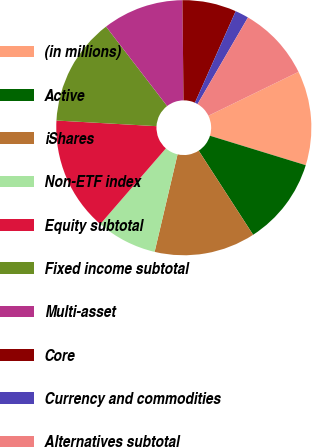<chart> <loc_0><loc_0><loc_500><loc_500><pie_chart><fcel>(in millions)<fcel>Active<fcel>iShares<fcel>Non-ETF index<fcel>Equity subtotal<fcel>Fixed income subtotal<fcel>Multi-asset<fcel>Core<fcel>Currency and commodities<fcel>Alternatives subtotal<nl><fcel>11.96%<fcel>11.11%<fcel>12.82%<fcel>7.69%<fcel>14.53%<fcel>13.67%<fcel>10.26%<fcel>6.84%<fcel>1.72%<fcel>9.4%<nl></chart> 